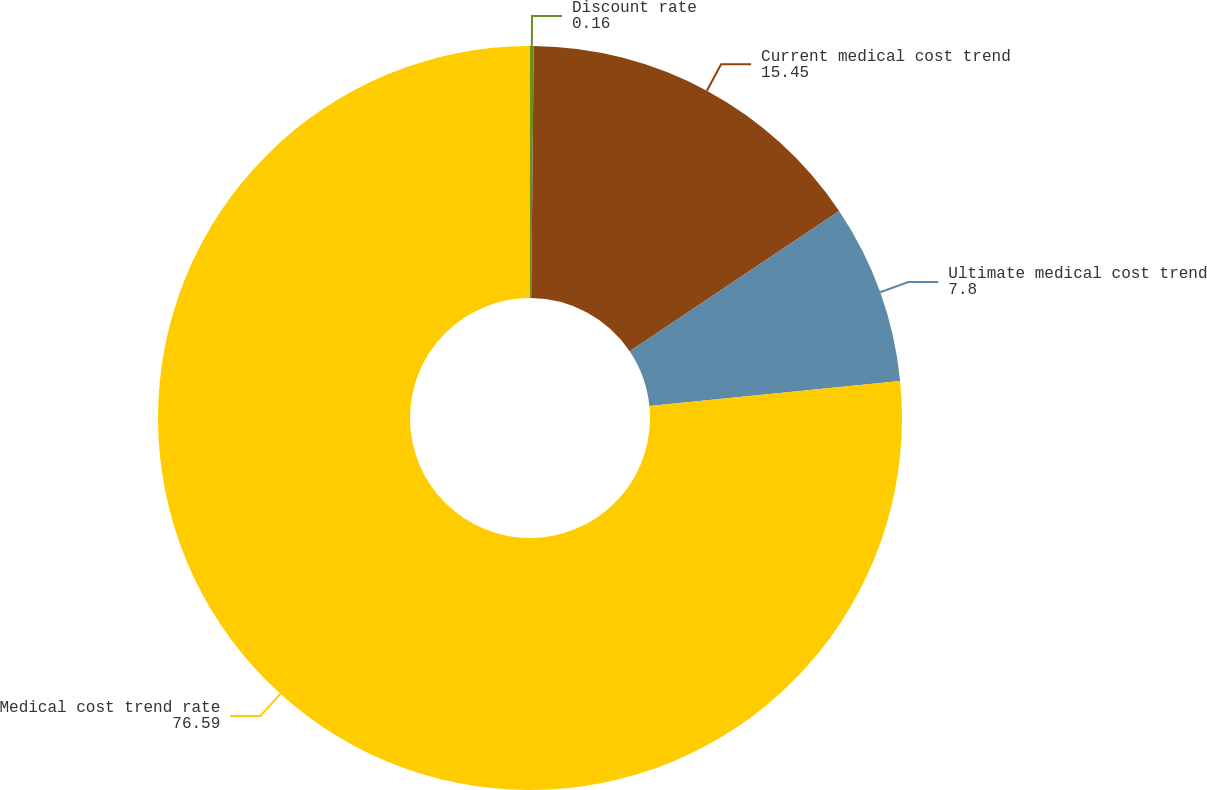<chart> <loc_0><loc_0><loc_500><loc_500><pie_chart><fcel>Discount rate<fcel>Current medical cost trend<fcel>Ultimate medical cost trend<fcel>Medical cost trend rate<nl><fcel>0.16%<fcel>15.45%<fcel>7.8%<fcel>76.59%<nl></chart> 